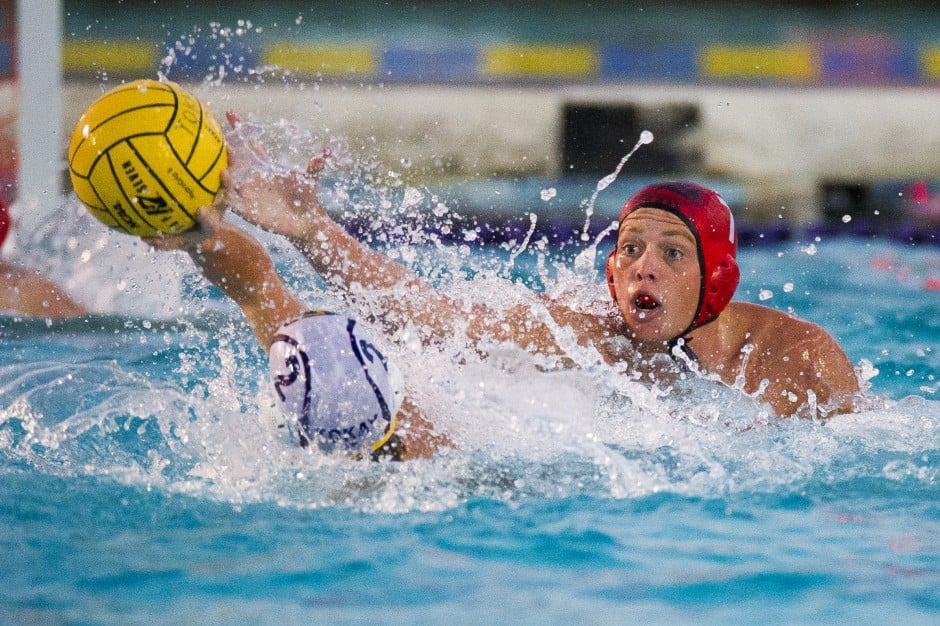Can you describe a likely outcome based on the current positioning of the players? Based on the current positioning, it seems probable that the player in the red cap will gain possession of the ball. They have extended their arm and appear to be in a more advantageous position with their hand closer to the ball compared to the player in the white cap. This positioning suggests that unless there is a sudden intervention or mistake, the red-capped player is more likely to successfully intercept the ball and potentially pass it to a teammate or make an offensive move. Nevertheless, the outcome remains dynamic and could change instantly with the swift and unpredictable nature of the game. Imagine this is the final play of the game. How might the players' actions reflect this high-stakes moment? In a high-stakes final play, every action is executed with heightened urgency and precision. The player in the red cap, recognizing the critical importance of securing the ball, might muster every ounce of their strength and agility to make a decisive move. Their focus is unwavering, blocking out distractions and aiming to outmaneuver the opponent in the white cap. The player in the white cap, equally aware of the significance, would be fiercely defending and attempting to regain control, possibly pushing their physical limits to block the interception. Their teammates would be strategically positioning themselves to either support a defensive block or quickly transition to offense, depending on who gains possession. The atmosphere is electric, knowing that this moment could determine the game's outcome and potentially their season's success, driving them to perform at their peak, showcasing their training, skills, and teamwork in this climactic play. What if instead of a water polo match, this was an underwater treasure hunt? In an imaginative twist where this scene is part of an underwater treasure hunt, the players transform into determined adventurers. The ball becomes a precious artifact, perhaps a golden orb or a gem that holds the key to a long-lost treasure. The player in the red cap, resembling a daring explorer, stretches out to claim the artifact, knowing that its retrieval is vital for unlocking the next clue or treasure chest. Meanwhile, the player in the white cap, another intrepid treasure seeker, strives to keep the artifact within their grasp, aware that letting it slip away might mean losing a significant advantage. The stakes reflect the thrill and excitement of discovery, where every move is driven by the hope of unearthing hidden riches and solving ancient mysteries. This reimagined scenario turns the athletic contest into a dramatic quest filled with adventure, risk, and the promise of great rewards. 